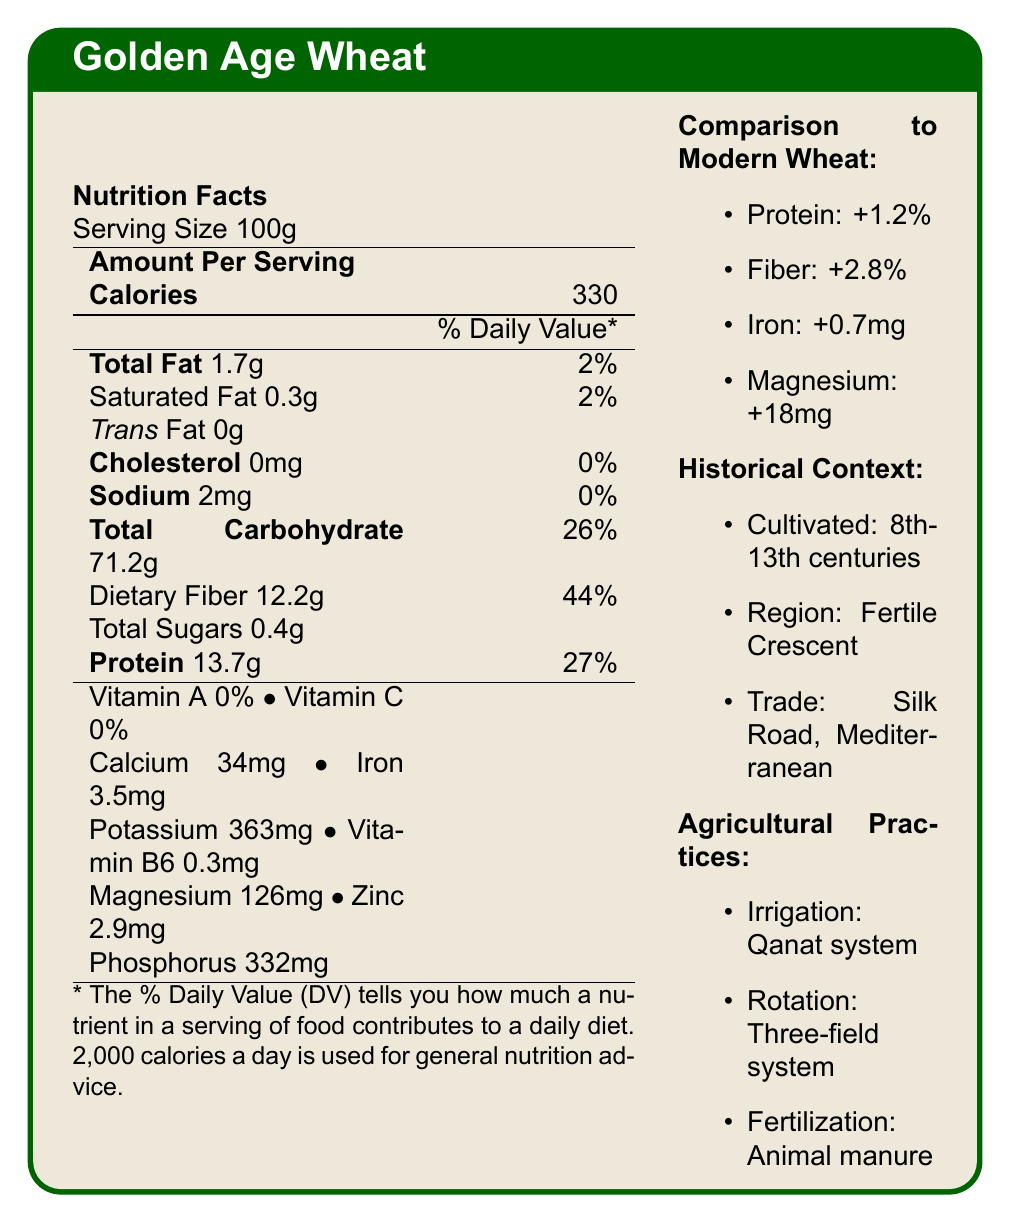What is the serving size for Golden Age Wheat? The serving size is listed at the top, under the "Nutrition Facts" section.
Answer: 100g How many calories are present in a 100g serving of Golden Age Wheat? The caloric content is listed in the "Amount Per Serving" section as 330 calories.
Answer: 330 What is the amount of dietary fiber in Golden Age Wheat per 100g serving? The amount of dietary fiber is listed under the "Total Carbohydrate" section as 12.2g.
Answer: 12.2g How much iron does a 100g serving of Golden Age Wheat provide? Iron content is listed towards the bottom of the table as 3.5mg.
Answer: 3.5mg What is the sodium content in Golden Age Wheat? The sodium content is listed under "Sodium" as 2mg.
Answer: 2mg What is the difference in protein content between Golden Age Wheat and modern wheat varieties? A. +0.5%, B. +1.2%, C. +2.0%, D. -1.2% The protein difference is listed under "Comparison to Modern Wheat" as +1.2%.
Answer: B. +1.2% Which irrigation method was used for cultivating Golden Age Wheat? A. Drip irrigation, B. Canal system, C. Sprinkler system, D. Qanat system The irrigation method is listed under "Agricultural Practices" as Qanat system.
Answer: D. Qanat system What time period was Golden Age Wheat cultivated? The cultivation period is mentioned in the "Historical Context" as 8th-13th centuries.
Answer: 8th-13th centuries True or False: Golden Age Wheat contains trans fat. The document specifies that trans fat content is 0g.
Answer: False Describe the main points presented in the document. The document details the nutritional content of Golden Age Wheat, its historical cultivation, comparison to modern wheat, and its cultural and agricultural significance during the Islamic Golden Age.
Answer: The document describes the nutritional facts of Golden Age Wheat, including its caloric content, macronutrients, and micronutrients per 100g serving. It compares its nutritional value to modern wheat varieties, noting differences in protein, fiber, iron, and magnesium content. It also provides historical context, noting that it was cultivated in the Fertile Crescent during the 8th-13th centuries and traded along the Silk Road and Mediterranean routes. It highlights agricultural practices like the Qanat irrigation system and crop rotation. The document also mentions notable scholars and the impact of Islamic agricultural knowledge on European agriculture. Who were some notable scholars mentioned in the document related to agriculture? The scholars Ibn al-Awwam and Al-Dinawari are mentioned under "notable scholars" along with their contributions.
Answer: Ibn al-Awwam and Al-Dinawari What percentage of the daily value for dietary fiber does Golden Age Wheat provide per 100g serving? The dietary fiber percentage is listed next to the amount under "Total Carbohydrate."
Answer: 44% Can you determine the exact farming tools used for cultivating Golden Age Wheat? The document does not specify the exact farming tools used, only irrigation methods, crop rotation, and fertilization practices.
Answer: Not enough information What impact did Golden Age Wheat and the agricultural practices have on European agriculture? The impact on European agriculture is described under "impact on European agriculture," mentioning knowledge transfer, crop introduction, and advanced irrigation techniques.
Answer: Knowledge transfer of agricultural texts, introduction of durum wheat, and adoption of advanced water management systems How much magnesium is present in Golden Age Wheat per 100g serving? The magnesium content is listed as 126mg under the nutrients section.
Answer: 126mg 